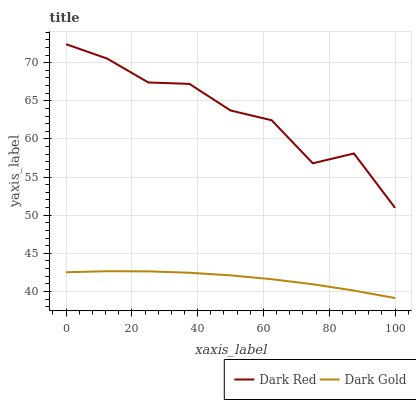Does Dark Gold have the maximum area under the curve?
Answer yes or no. No. Is Dark Gold the roughest?
Answer yes or no. No. Does Dark Gold have the highest value?
Answer yes or no. No. Is Dark Gold less than Dark Red?
Answer yes or no. Yes. Is Dark Red greater than Dark Gold?
Answer yes or no. Yes. Does Dark Gold intersect Dark Red?
Answer yes or no. No. 